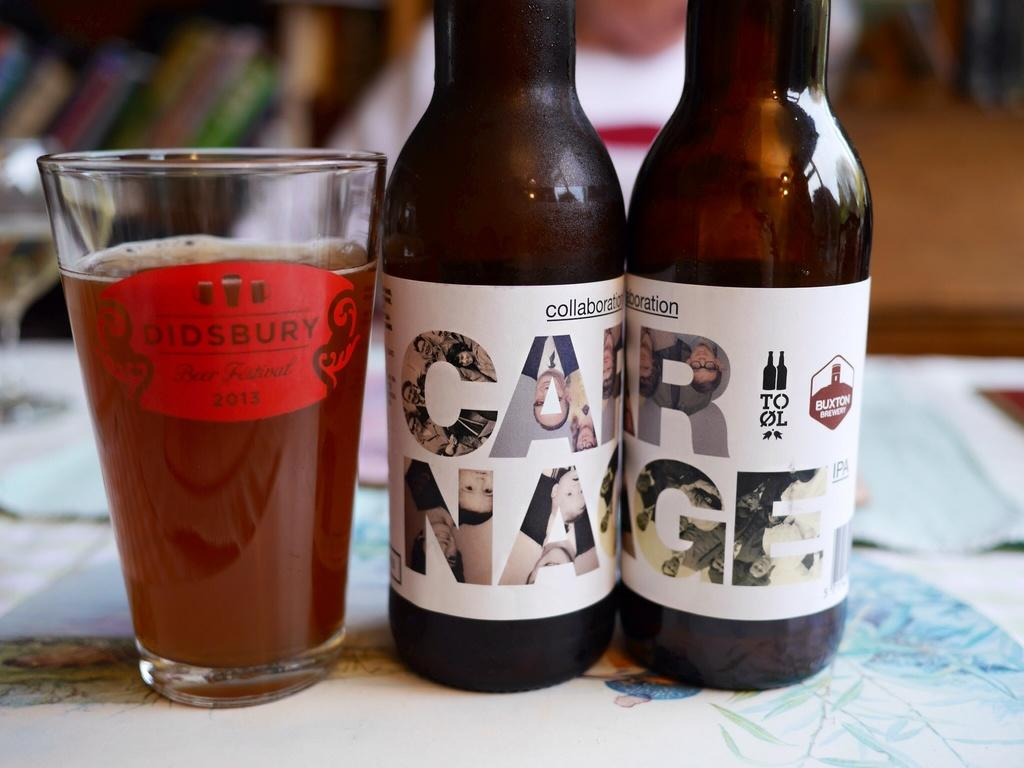<image>
Summarize the visual content of the image. 2 glass bottles of Carnage next to a glass 